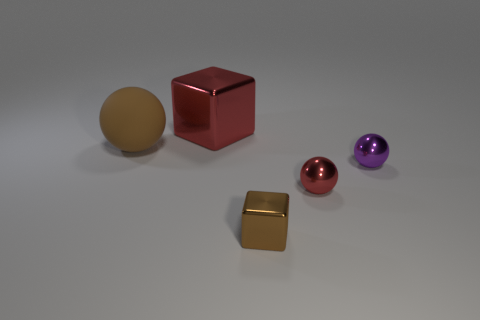What number of green metallic things have the same size as the red shiny sphere?
Ensure brevity in your answer.  0. Is the number of metallic objects in front of the large brown matte sphere greater than the number of small purple metal things on the left side of the brown metallic block?
Offer a very short reply. Yes. There is a brown thing that is the same size as the red block; what is its material?
Ensure brevity in your answer.  Rubber. What shape is the big red shiny thing?
Provide a succinct answer. Cube. How many purple things are either tiny cubes or small matte cylinders?
Provide a succinct answer. 0. The purple sphere that is the same material as the red cube is what size?
Provide a short and direct response. Small. Do the brown cube that is on the right side of the brown rubber ball and the red thing behind the big matte thing have the same material?
Offer a very short reply. Yes. What number of cylinders are either cyan matte objects or big red metal things?
Your answer should be very brief. 0. There is a red metallic object to the right of the shiny block in front of the purple shiny ball; what number of small shiny spheres are on the right side of it?
Your response must be concise. 1. What is the material of the tiny red object that is the same shape as the big brown rubber thing?
Your answer should be very brief. Metal. 